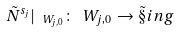<formula> <loc_0><loc_0><loc_500><loc_500>\tilde { N } ^ { s _ { j } } | _ { \ W _ { j , 0 } } \colon \ W _ { j , 0 } \to \tilde { \S } i n g</formula> 